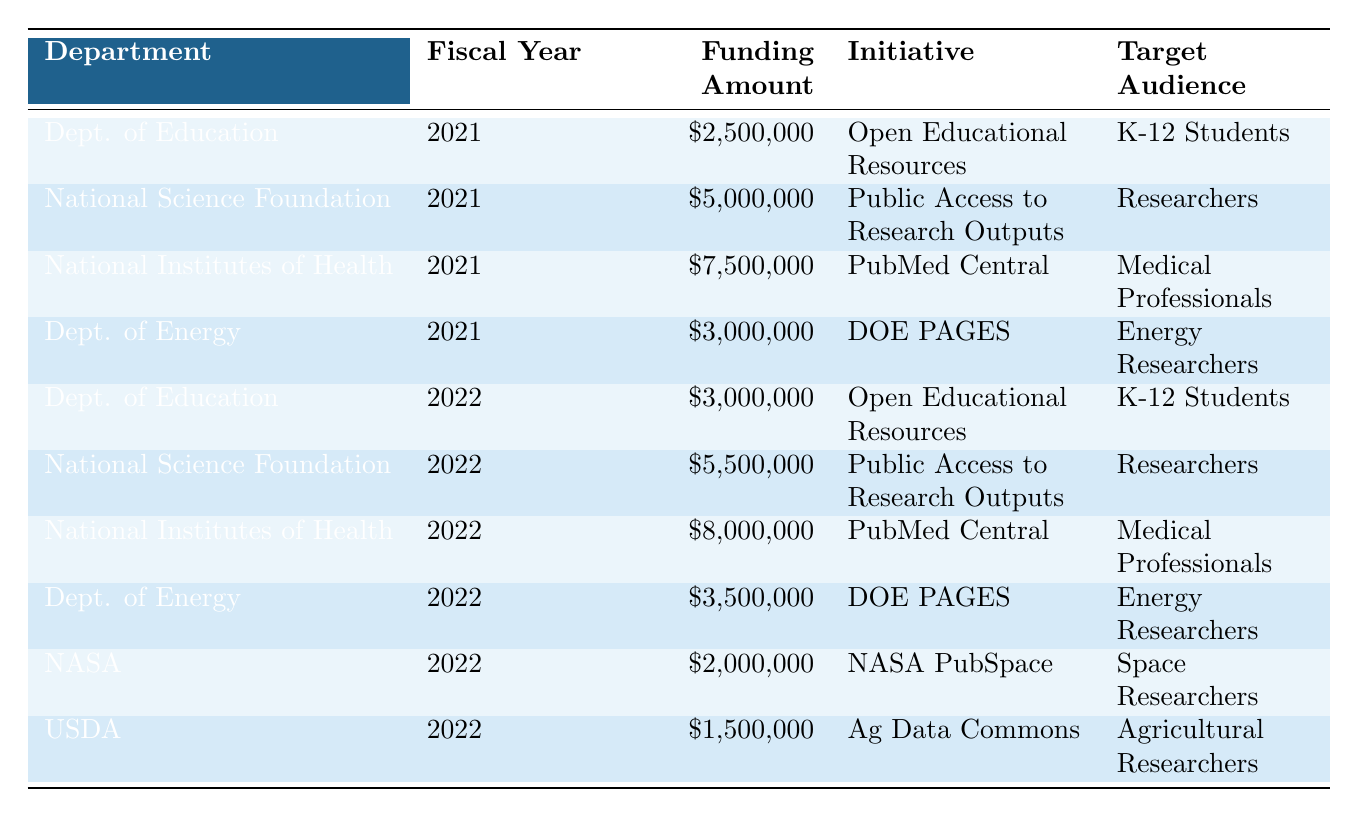What is the total funding allocated by the National Institutes of Health for open access initiatives in 2021 and 2022? The funding amounts from the National Institutes of Health for the years 2021 and 2022 are $7,500,000 and $8,000,000, respectively. Adding them gives $7,500,000 + $8,000,000 = $15,500,000.
Answer: $15,500,000 Which department allocated the highest amount of funding in 2022? The table shows that the National Institutes of Health allocated $8,000,000, which is the highest funding amount in 2022.
Answer: National Institutes of Health How much funding did the Department of Education receive in 2021? According to the table, the Department of Education received $2,500,000 in funding in 2021.
Answer: $2,500,000 Did the funding for Open Educational Resources increase from 2021 to 2022? The funding for Open Educational Resources was $2,500,000 in 2021 and increased to $3,000,000 in 2022. Since $3,000,000 is greater than $2,500,000, it did increase.
Answer: Yes What is the average funding amount for the Department of Energy across 2021 and 2022? The Department of Energy received $3,000,000 in 2021 and $3,500,000 in 2022. The total of these amounts is $3,000,000 + $3,500,000 = $6,500,000. Dividing this by 2 gives an average of $6,500,000 / 2 = $3,250,000.
Answer: $3,250,000 Which initiatives targeted K-12 Students? The initiatives targeting K-12 Students listed in the table are "Open Educational Resources" for both 2021 and 2022.
Answer: Open Educational Resources What percentage of the total funding for 2022 did the USDA receive? The total funding for 2022 is $3,000,000 (Education) + $5,500,000 (NSF) + $8,000,000 (NIH) + $3,500,000 (Energy) + $2,000,000 (NASA) + $1,500,000 (USDA) = $23,500,000. The USDA received $1,500,000, which is ($1,500,000 / $23,500,000) * 100 = 6.38% of the total funding for 2022.
Answer: 6.38% In which fiscal year was the funding for "NASA PubSpace" allocated? The "NASA PubSpace" initiative was allocated funding in the fiscal year 2022, as listed in the table.
Answer: 2022 Is the funding for "Ag Data Commons" higher or lower than that for "NASA PubSpace"? The funding for "Ag Data Commons" is $1,500,000 and for "NASA PubSpace" it is $2,000,000. Since $1,500,000 is lower than $2,000,000, the funding for "Ag Data Commons" is lower.
Answer: Lower What was the total increase in funding for the National Science Foundation from 2021 to 2022? The funding for the National Science Foundation in 2021 was $5,000,000, and in 2022 it was $5,500,000. The increase is $5,500,000 - $5,000,000 = $500,000.
Answer: $500,000 